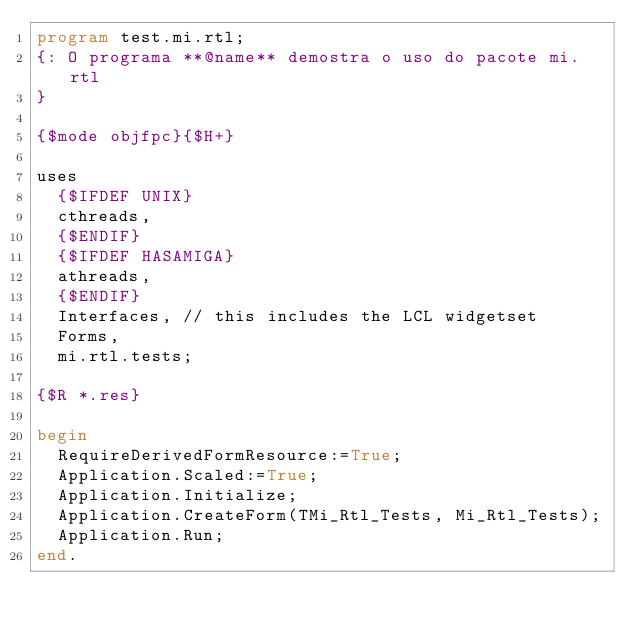Convert code to text. <code><loc_0><loc_0><loc_500><loc_500><_Pascal_>program test.mi.rtl;
{: O programa **@name** demostra o uso do pacote mi.rtl
}

{$mode objfpc}{$H+}

uses
  {$IFDEF UNIX}
  cthreads,
  {$ENDIF}
  {$IFDEF HASAMIGA}
  athreads,
  {$ENDIF}
  Interfaces, // this includes the LCL widgetset
  Forms,
  mi.rtl.tests;

{$R *.res}

begin
  RequireDerivedFormResource:=True;
  Application.Scaled:=True;
  Application.Initialize;
  Application.CreateForm(TMi_Rtl_Tests, Mi_Rtl_Tests);
  Application.Run;
end.

</code> 